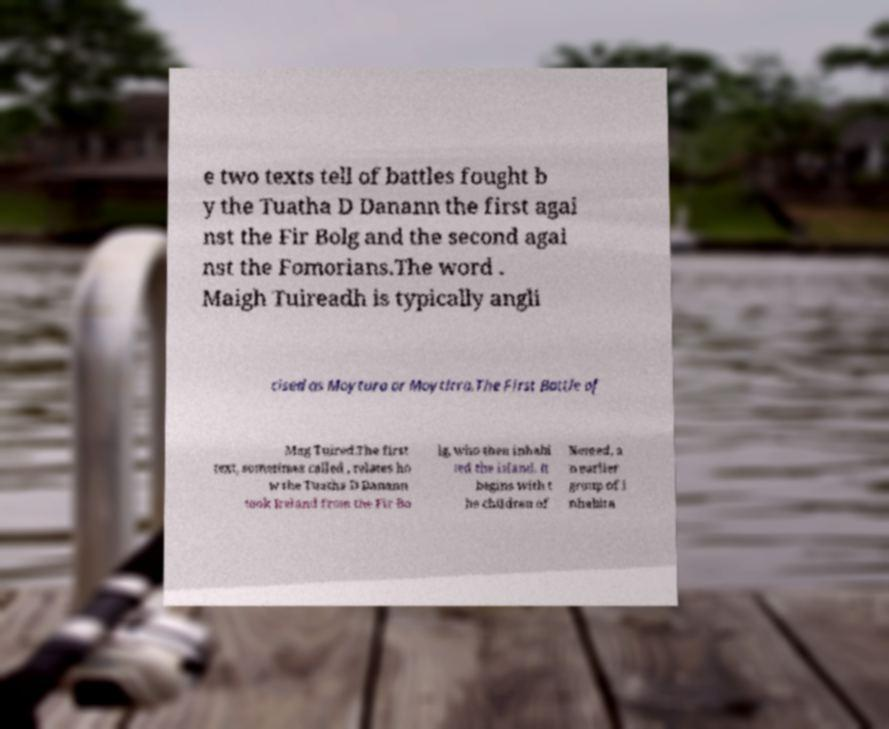Please read and relay the text visible in this image. What does it say? e two texts tell of battles fought b y the Tuatha D Danann the first agai nst the Fir Bolg and the second agai nst the Fomorians.The word . Maigh Tuireadh is typically angli cised as Moytura or Moytirra.The First Battle of Mag Tuired.The first text, sometimes called , relates ho w the Tuatha D Danann took Ireland from the Fir Bo lg, who then inhabi ted the island. It begins with t he children of Nemed, a n earlier group of i nhabita 